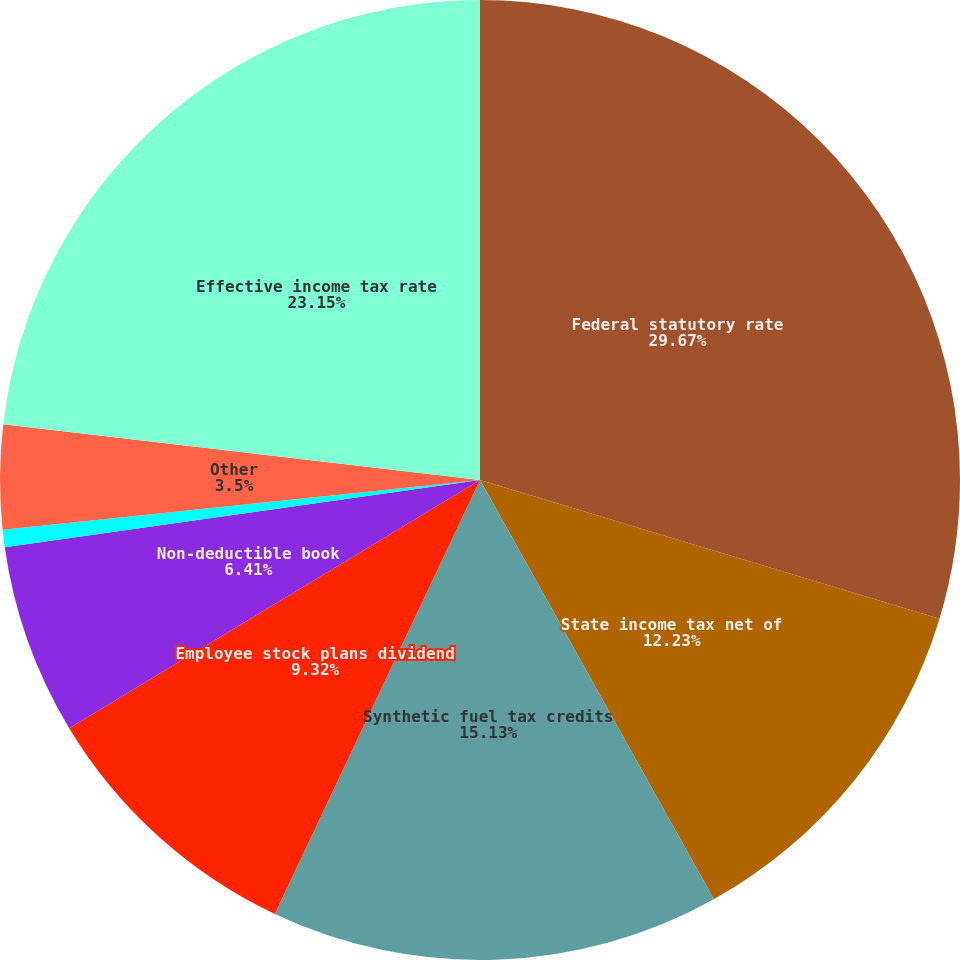Convert chart. <chart><loc_0><loc_0><loc_500><loc_500><pie_chart><fcel>Federal statutory rate<fcel>State income tax net of<fcel>Synthetic fuel tax credits<fcel>Employee stock plans dividend<fcel>Non-deductible book<fcel>Difference in prior years'<fcel>Other<fcel>Effective income tax rate<nl><fcel>29.67%<fcel>12.23%<fcel>15.13%<fcel>9.32%<fcel>6.41%<fcel>0.59%<fcel>3.5%<fcel>23.15%<nl></chart> 